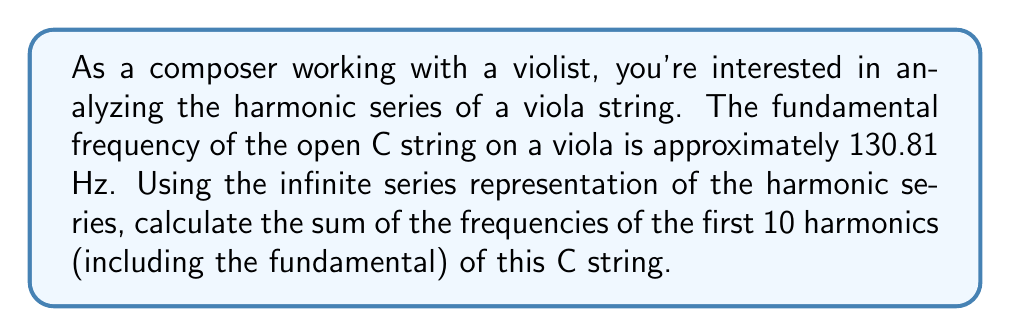Show me your answer to this math problem. To solve this problem, we'll follow these steps:

1) The harmonic series of a musical note can be represented as an infinite series where each term is a multiple of the fundamental frequency. For a fundamental frequency $f$, the series is:

   $$ f + 2f + 3f + 4f + ... $$

2) In this case, our fundamental frequency $f = 130.81$ Hz.

3) We need to find the sum of the first 10 terms of this series. This can be represented as:

   $$ S = \sum_{n=1}^{10} nf $$

4) We can factor out $f$ from this sum:

   $$ S = f \sum_{n=1}^{10} n $$

5) The sum of the first $n$ positive integers is given by the formula:

   $$ \sum_{n=1}^{n} n = \frac{n(n+1)}{2} $$

6) In our case, $n = 10$, so:

   $$ \sum_{n=1}^{10} n = \frac{10(10+1)}{2} = \frac{10(11)}{2} = 55 $$

7) Substituting this back into our equation:

   $$ S = 130.81 \cdot 55 = 7194.55 \text{ Hz} $$

Thus, the sum of the frequencies of the first 10 harmonics is 7194.55 Hz.
Answer: 7194.55 Hz 